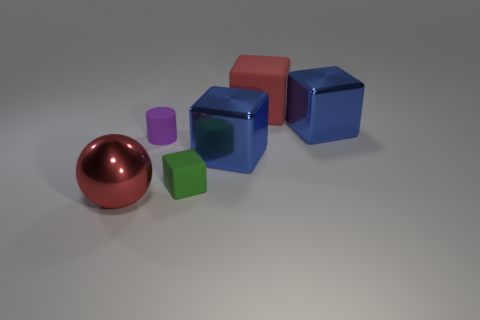Subtract all green rubber blocks. How many blocks are left? 3 Add 4 red spheres. How many objects exist? 10 Subtract all red blocks. How many blocks are left? 3 Subtract all cylinders. How many objects are left? 5 Subtract 1 cubes. How many cubes are left? 3 Subtract 0 yellow cylinders. How many objects are left? 6 Subtract all red cylinders. Subtract all cyan balls. How many cylinders are left? 1 Subtract all blue cubes. How many green cylinders are left? 0 Subtract all tiny gray rubber things. Subtract all rubber cubes. How many objects are left? 4 Add 2 small green matte blocks. How many small green matte blocks are left? 3 